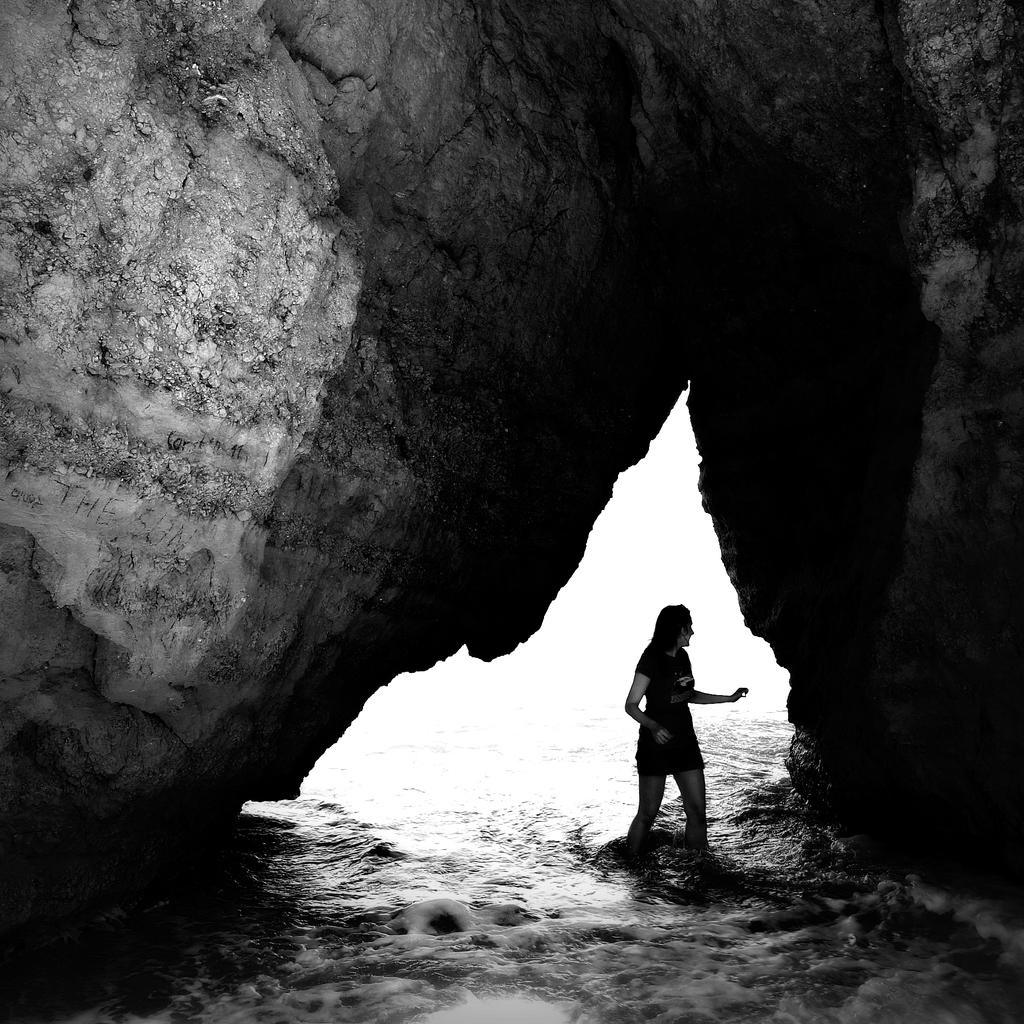What is the person in the image doing? The person is standing in the water. What can be seen above the person in the image? There is a rock above the person. What is the color scheme of the image? The image is black and white. What type of nerve can be seen in the person's hand in the image? There is no nerve visible in the person's hand in the image. Can you tell me how many basketballs are present in the image? There are no basketballs present in the image. 